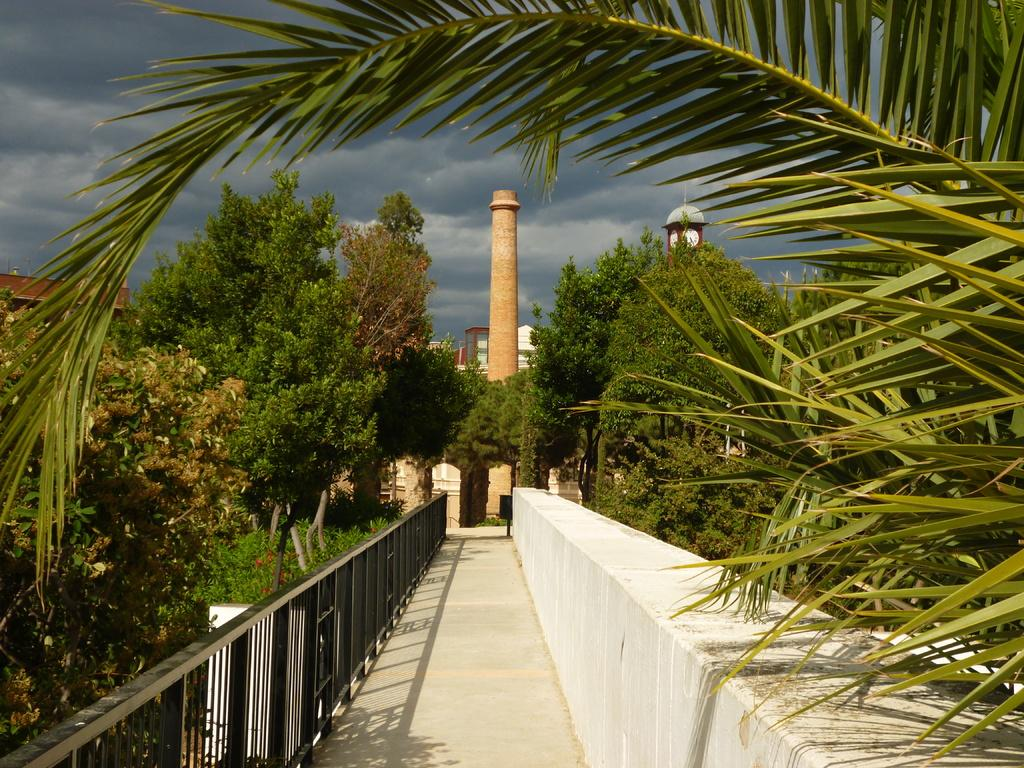What is the main structure in the image? There is a tower in the image. What other structures can be seen in the image? There is a building in the image. What type of vegetation is present in the image? There are trees in the image. What type of barrier is at the bottom of the image? There is black fencing at the bottom of the image. What is the other feature at the bottom of the image? There is a wall at the bottom of the image. What is visible in the top left corner of the image? The sky is visible in the top left corner of the image, and clouds are present there. What type of juice is being served in the image? There is no juice present in the image. Can you see a toothbrush in the image? There is no toothbrush present in the image. 